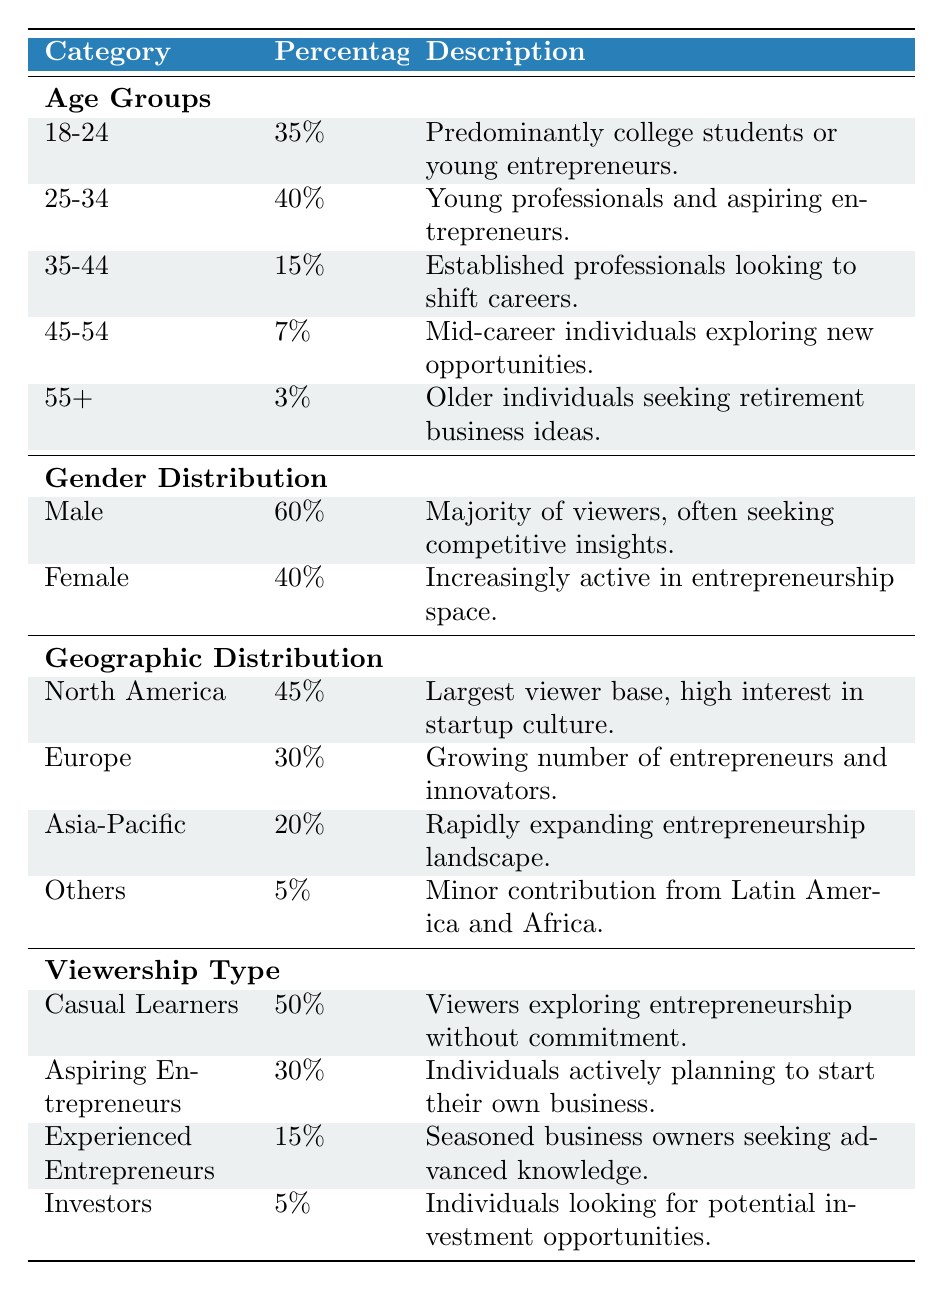What percentage of viewers are aged 25-34? From the "Age Groups" section of the table, we find the specific row for the age range 25-34, which shows the percentage as 40%.
Answer: 40% Which gender has a higher percentage among viewers? The table provides a comparison between male and female viewers. Male viewers account for 60%, while female viewers account for 40%. This tells us that male viewers have a higher percentage.
Answer: Male What is the total percentage of viewers from North America and Europe? To find the combined percentage of viewers from North America and Europe, we add their individual percentages: North America (45%) + Europe (30%) = 75%.
Answer: 75% Is the percentage of experienced entrepreneurs greater than casual learners? The table indicates that experienced entrepreneurs make up 15% of the viewers and casual learners constitute 50%. Since 15% is less than 50%, the answer is no.
Answer: No What is the average percentage of viewers aged 35-54? We calculate the average percentage of viewers in the age groups 35-44 (15%) and 45-54 (7%). The average is calculated as (15 + 7) / 2 = 11%.
Answer: 11% How many viewers are from the Asia-Pacific region and others combined? From the table, Asia-Pacific represents 20% and the "Others" category combines for 5%. Adding these percentages gives us: 20% + 5% = 25%.
Answer: 25% Is there a minority in the gender distribution? When comparing the percentages of male (60%) and female (40%) viewers, we see that 40% represents less than half, qualifying it as a minority in gender distribution. Therefore, the answer is yes.
Answer: Yes What percentage of the audience consists of aspiring entrepreneurs and casual learners? To find this combined percentage, we simply add the two categories: aspiring entrepreneurs (30%) and casual learners (50%) = 80%.
Answer: 80% How do the percentages of viewers in North America and Asia compare? The percentage of viewers in North America is 45%, while in Asia-Pacific, it is 20%. Since 45% is greater than 20%, it indicates North America has a higher viewer percentage.
Answer: North America has a higher percentage 